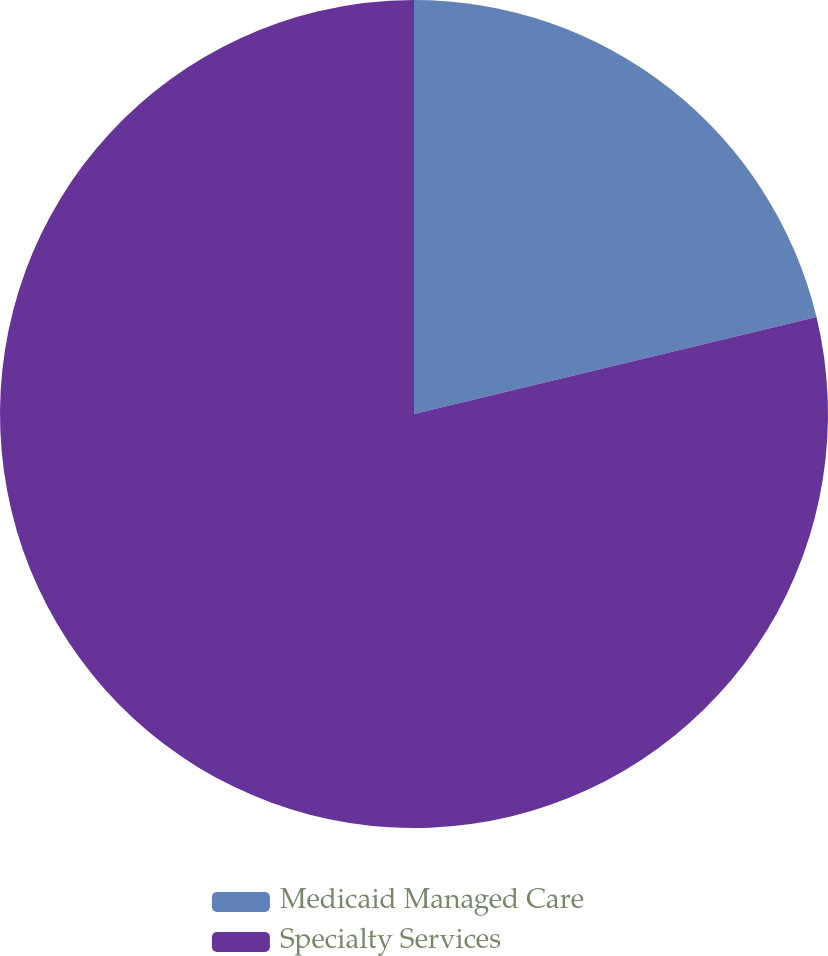Convert chart to OTSL. <chart><loc_0><loc_0><loc_500><loc_500><pie_chart><fcel>Medicaid Managed Care<fcel>Specialty Services<nl><fcel>21.24%<fcel>78.76%<nl></chart> 